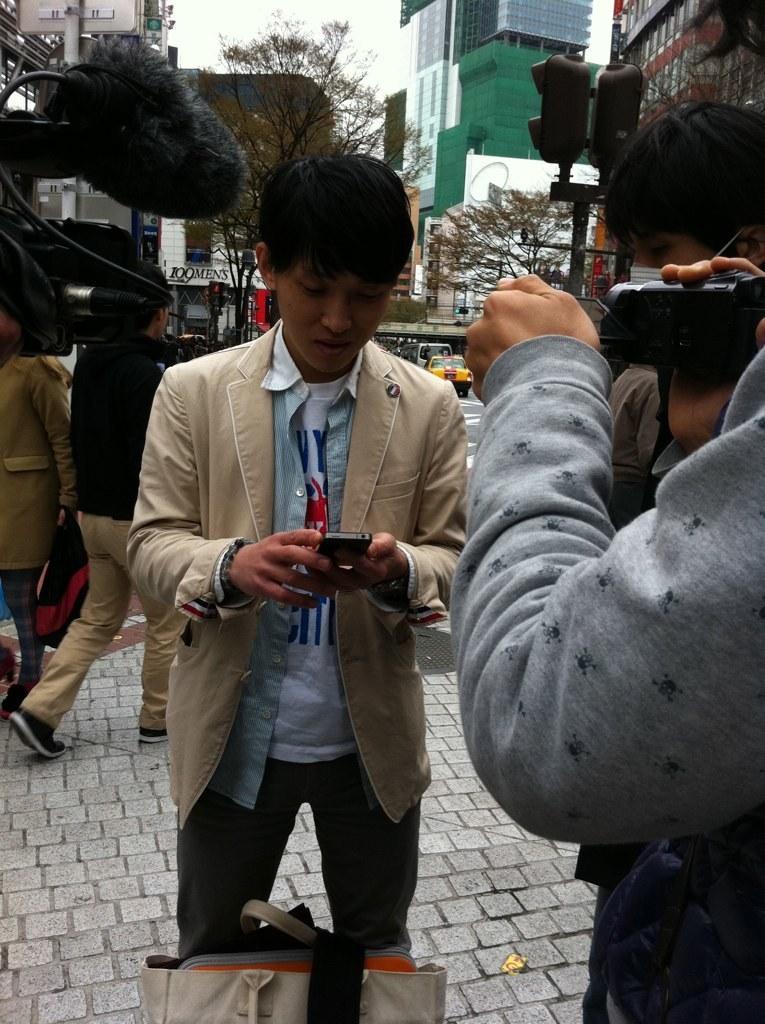How would you summarize this image in a sentence or two? In this image I can see few people are standing. I can also see few cameras, a bag, few trees, number of buildings, a pole, few vehicles and over there I can see something is written. I can see he is holding a phone. 